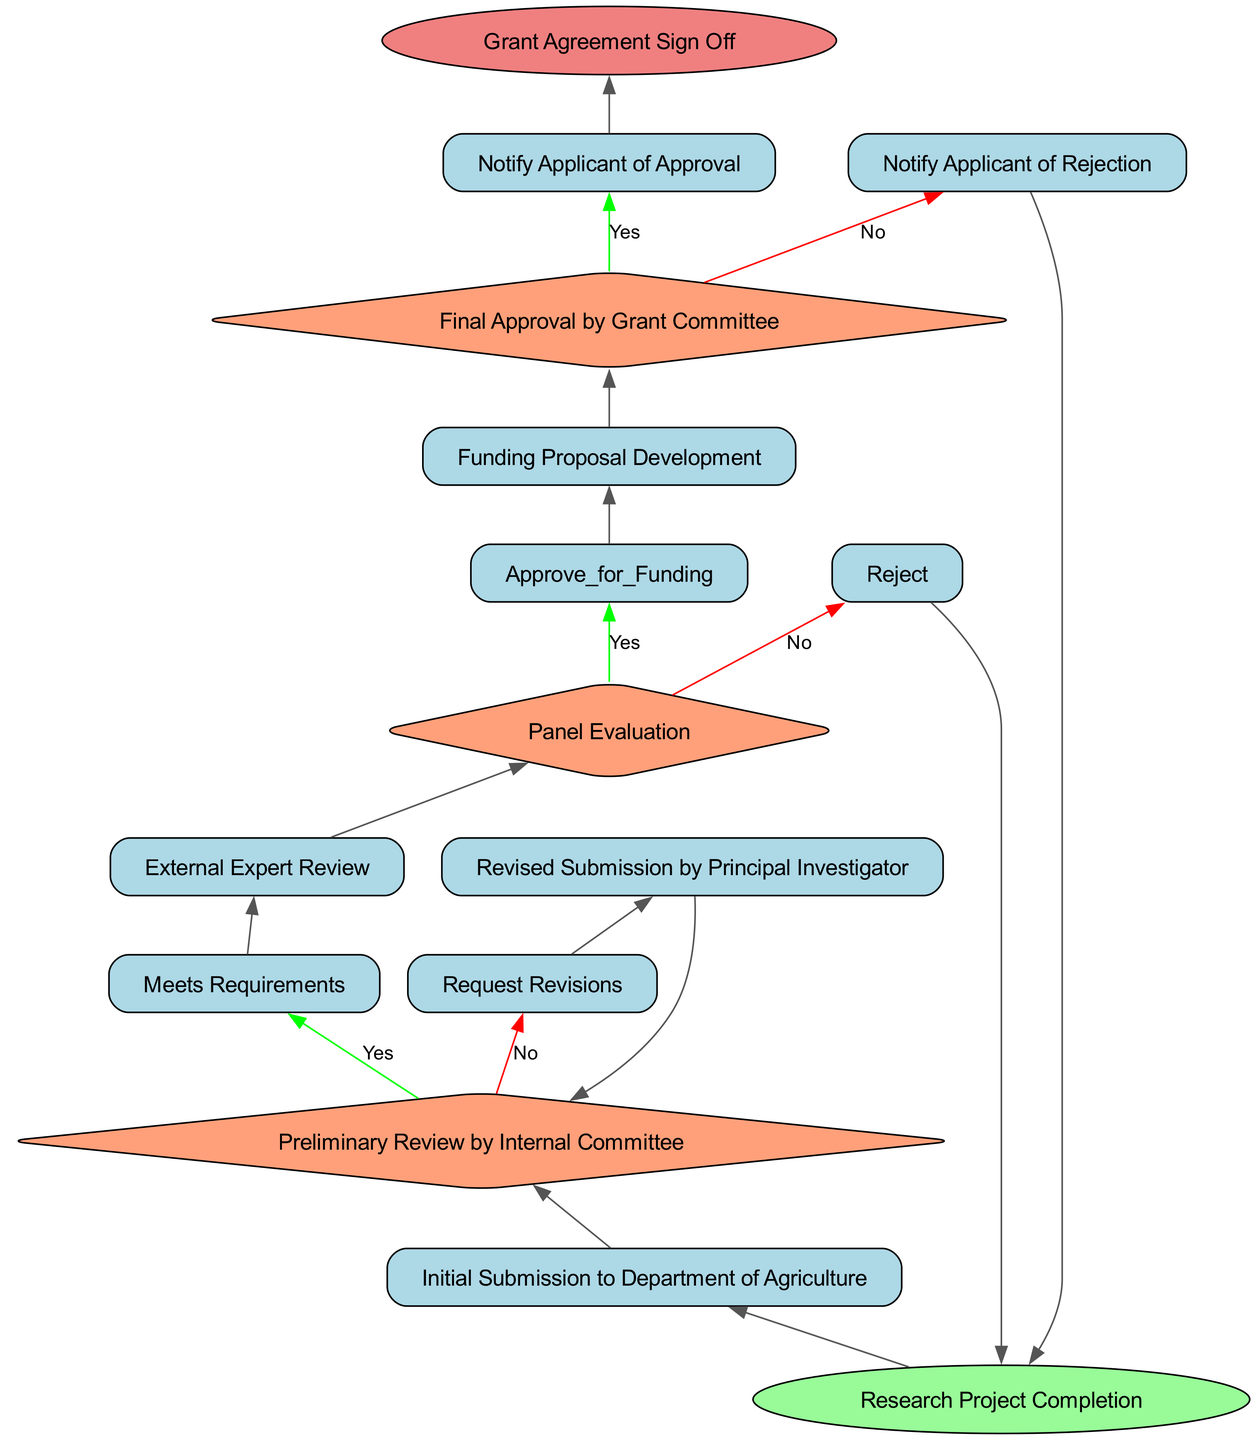What is the starting point of the process? The first node in the flowchart is labeled "Research Project Completion," which indicates the starting point of the evaluation and approval process.
Answer: Research Project Completion What happens after the "Initial Submission to Department of Agriculture"? After this node, the next step in the flowchart is "Preliminary Review by Internal Committee," which follows directly from the initial submission.
Answer: Preliminary Review by Internal Committee What are the two potential outcomes of the "Panel Evaluation" decision? The flowchart indicates that the outcomes are "Approve for Funding" and "Reject," showing the two paths that can be taken from this decision point.
Answer: Approve for Funding, Reject How many nodes are there in total in the diagram? By counting each unique component represented in the diagram, we find there are 13 nodes in total, including start, process, decision, and end nodes.
Answer: 13 What action follows the “Revised Submission by Principal Investigator”? The process leads back to the "Preliminary Review by Internal Committee" after this action, indicating that revisions trigger a new review cycle.
Answer: Preliminary Review by Internal Committee What does the process conclude with? The final step in the flowchart is indicated by the node labeled "Grant Agreement Sign Off," which serves as the conclusion of the entire process.
Answer: Grant Agreement Sign Off What is the result if the "Preliminary Review by Internal Committee" indicates that requirements are not met? If the requirements are not met, the process directs to "Request Revisions," showcasing the need for the principal investigator to amend their submission.
Answer: Request Revisions How many decision nodes appear in the diagram? There are three decision nodes present in the flowchart, which are critical points where outcomes can direct the flow to different further steps.
Answer: 3 What is the purpose of the "External Expert Review"? This node acts as a process step that helps assess and evaluate the grant proposal prior to the "Panel Evaluation," which is necessary for ensuring quality and feasibility of the proposal.
Answer: Assess and evaluate the grant proposal 